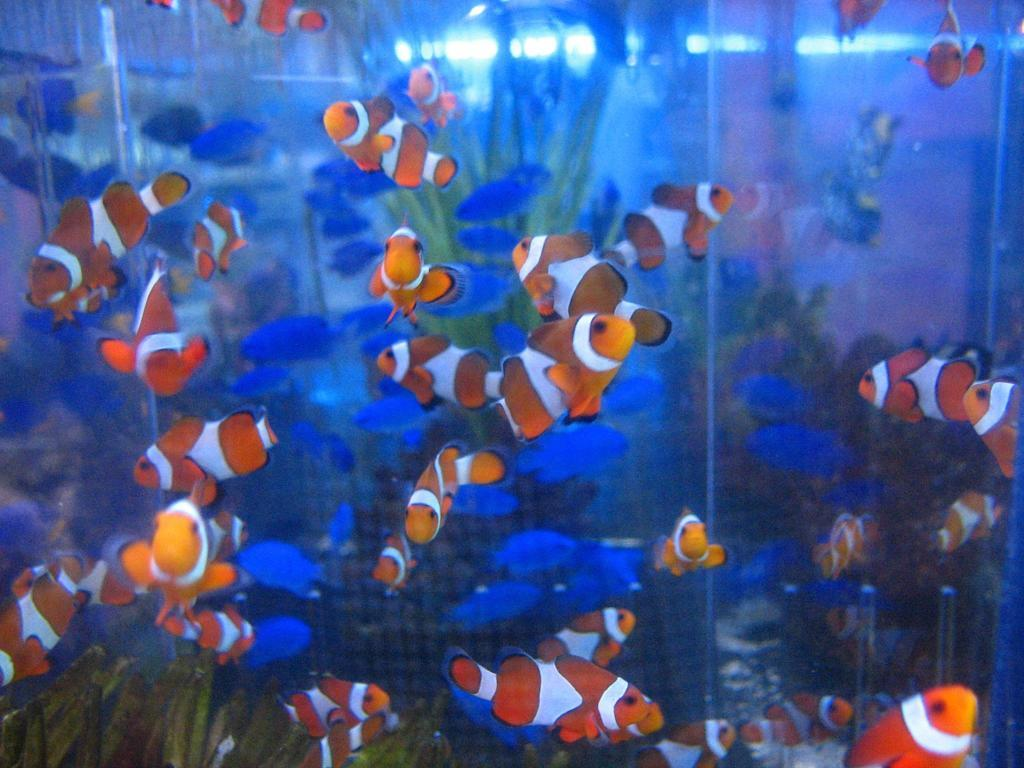What is the main subject of the image? The image is a zoomed-in picture of an aquarium. What types of fish can be seen in the aquarium? There are orange and white combination fishes in the aquarium. What type of representative is present in the aquarium? There is no representative present in the aquarium; it is a picture of an aquarium with fish. Can you touch the cow in the image? There is no cow present in the image; it is a picture of an aquarium with fish. 